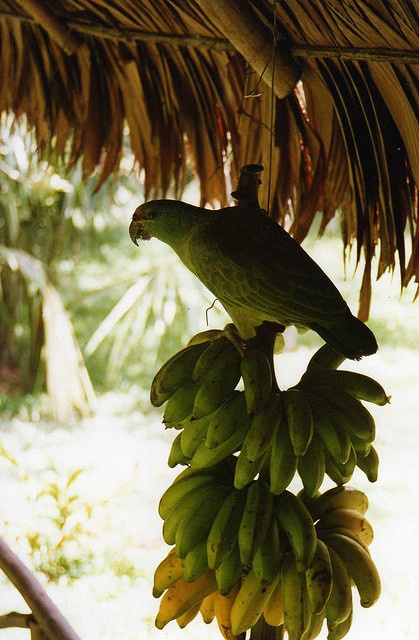Describe the objects in this image and their specific colors. I can see banana in maroon, black, and olive tones and bird in maroon, black, olive, and beige tones in this image. 